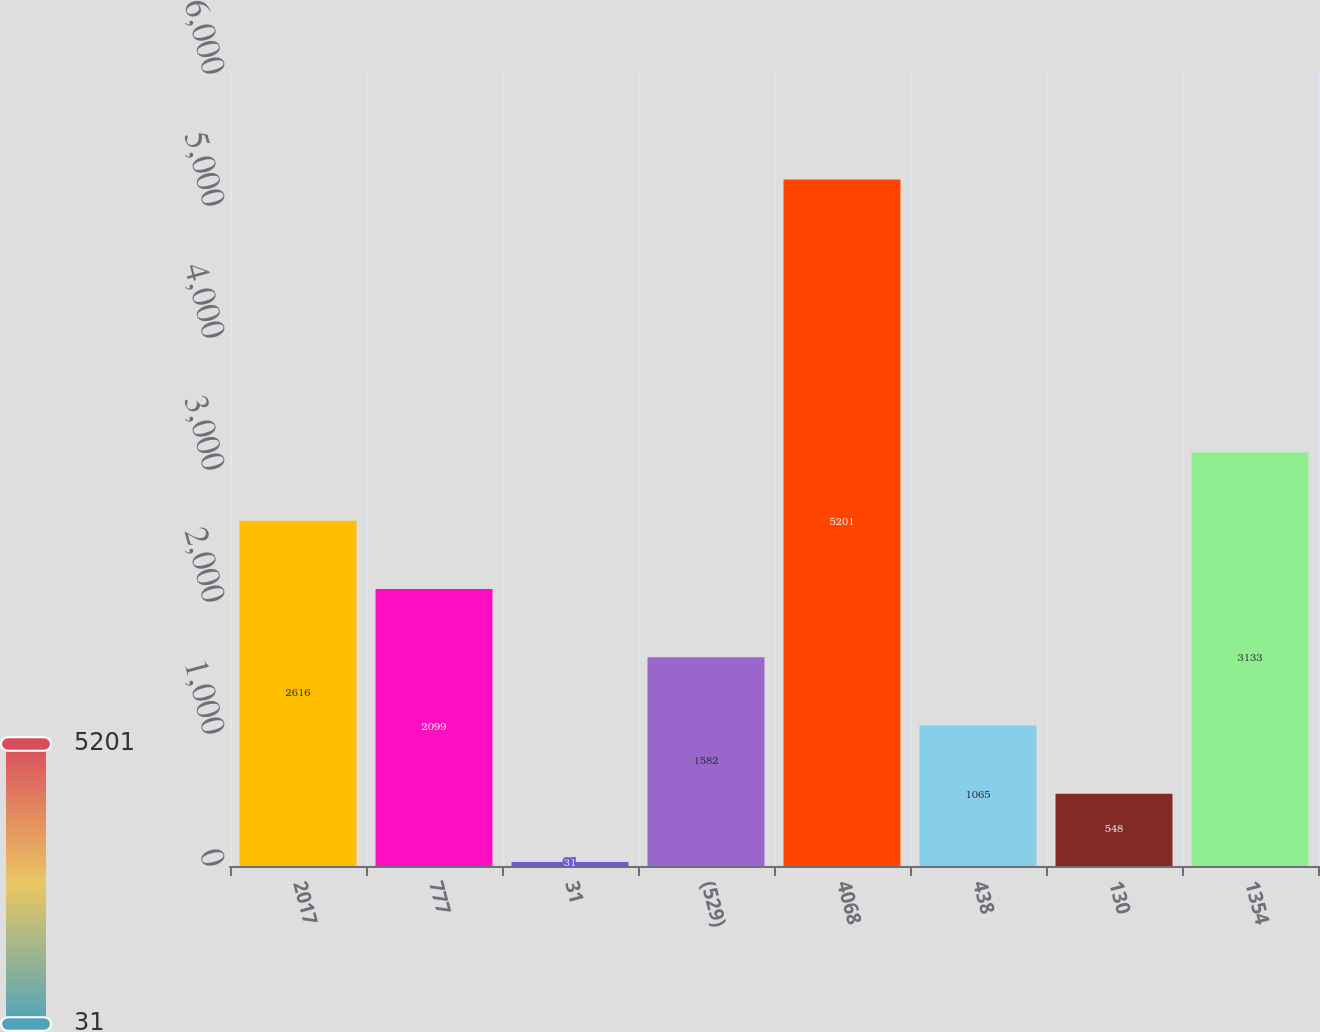Convert chart. <chart><loc_0><loc_0><loc_500><loc_500><bar_chart><fcel>2017<fcel>777<fcel>31<fcel>(529)<fcel>4068<fcel>438<fcel>130<fcel>1354<nl><fcel>2616<fcel>2099<fcel>31<fcel>1582<fcel>5201<fcel>1065<fcel>548<fcel>3133<nl></chart> 